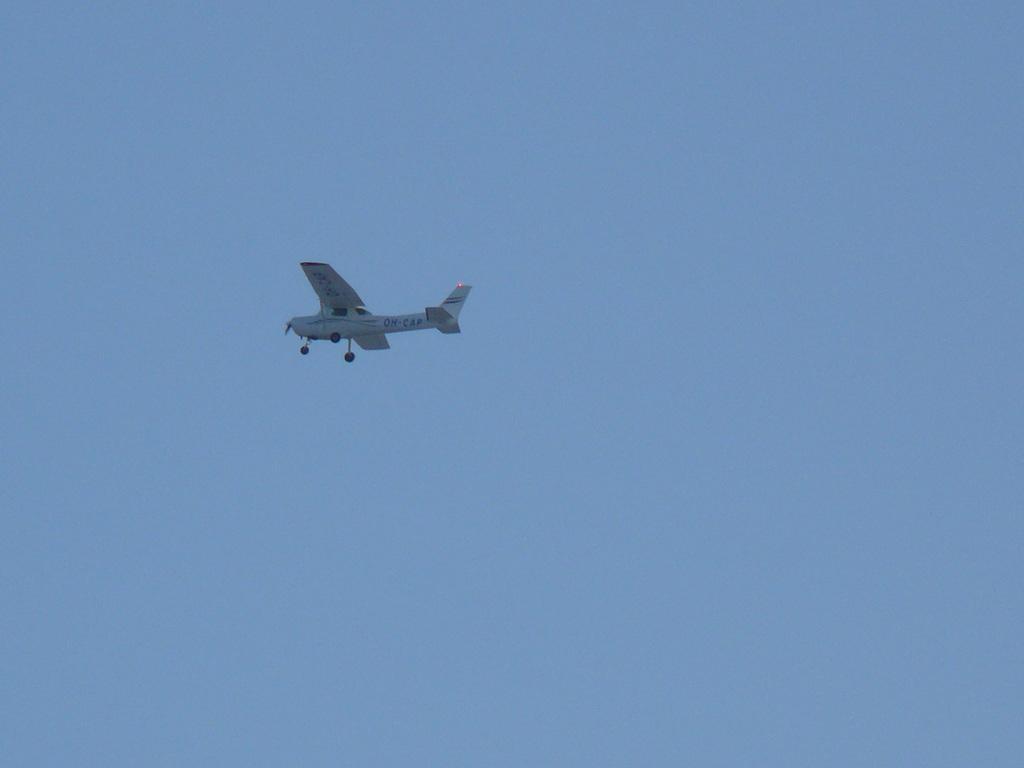Please provide a concise description of this image. In this image there is an airplane in the sky. 